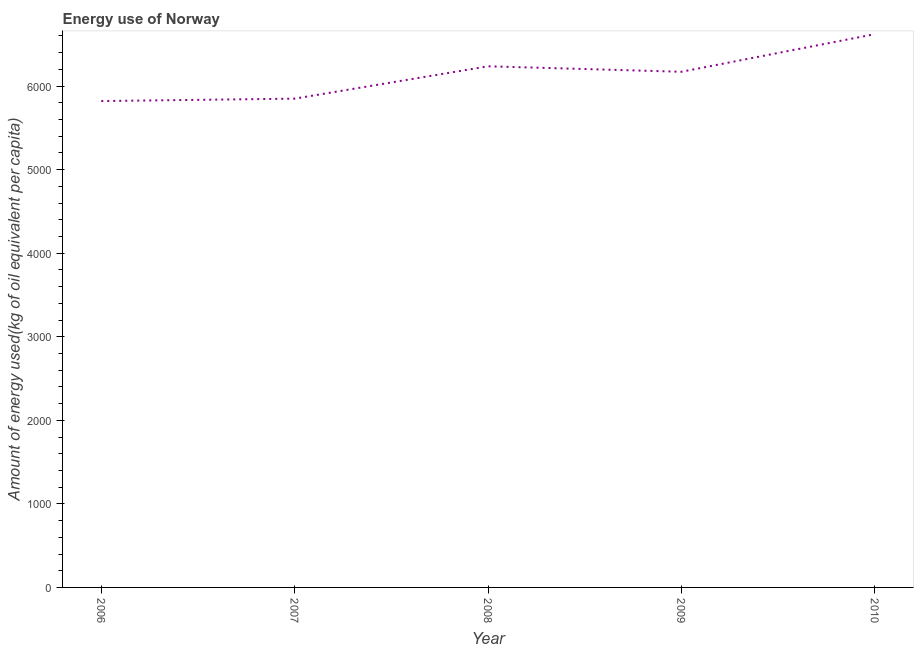What is the amount of energy used in 2006?
Your answer should be very brief. 5820.81. Across all years, what is the maximum amount of energy used?
Offer a very short reply. 6621.38. Across all years, what is the minimum amount of energy used?
Offer a terse response. 5820.81. In which year was the amount of energy used minimum?
Your answer should be compact. 2006. What is the sum of the amount of energy used?
Ensure brevity in your answer.  3.07e+04. What is the difference between the amount of energy used in 2006 and 2009?
Give a very brief answer. -350.56. What is the average amount of energy used per year?
Keep it short and to the point. 6140.03. What is the median amount of energy used?
Keep it short and to the point. 6171.37. In how many years, is the amount of energy used greater than 4800 kg?
Provide a short and direct response. 5. Do a majority of the years between 2010 and 2007 (inclusive) have amount of energy used greater than 4200 kg?
Provide a short and direct response. Yes. What is the ratio of the amount of energy used in 2007 to that in 2008?
Offer a terse response. 0.94. Is the amount of energy used in 2008 less than that in 2009?
Offer a terse response. No. What is the difference between the highest and the second highest amount of energy used?
Make the answer very short. 384.53. What is the difference between the highest and the lowest amount of energy used?
Offer a terse response. 800.57. In how many years, is the amount of energy used greater than the average amount of energy used taken over all years?
Your answer should be compact. 3. How many years are there in the graph?
Give a very brief answer. 5. What is the difference between two consecutive major ticks on the Y-axis?
Keep it short and to the point. 1000. Does the graph contain any zero values?
Ensure brevity in your answer.  No. Does the graph contain grids?
Your answer should be very brief. No. What is the title of the graph?
Keep it short and to the point. Energy use of Norway. What is the label or title of the Y-axis?
Your answer should be very brief. Amount of energy used(kg of oil equivalent per capita). What is the Amount of energy used(kg of oil equivalent per capita) in 2006?
Offer a very short reply. 5820.81. What is the Amount of energy used(kg of oil equivalent per capita) in 2007?
Provide a succinct answer. 5849.73. What is the Amount of energy used(kg of oil equivalent per capita) in 2008?
Give a very brief answer. 6236.85. What is the Amount of energy used(kg of oil equivalent per capita) of 2009?
Provide a short and direct response. 6171.37. What is the Amount of energy used(kg of oil equivalent per capita) of 2010?
Provide a short and direct response. 6621.38. What is the difference between the Amount of energy used(kg of oil equivalent per capita) in 2006 and 2007?
Make the answer very short. -28.93. What is the difference between the Amount of energy used(kg of oil equivalent per capita) in 2006 and 2008?
Your answer should be very brief. -416.04. What is the difference between the Amount of energy used(kg of oil equivalent per capita) in 2006 and 2009?
Your answer should be compact. -350.56. What is the difference between the Amount of energy used(kg of oil equivalent per capita) in 2006 and 2010?
Your answer should be compact. -800.57. What is the difference between the Amount of energy used(kg of oil equivalent per capita) in 2007 and 2008?
Your response must be concise. -387.12. What is the difference between the Amount of energy used(kg of oil equivalent per capita) in 2007 and 2009?
Your answer should be very brief. -321.64. What is the difference between the Amount of energy used(kg of oil equivalent per capita) in 2007 and 2010?
Keep it short and to the point. -771.64. What is the difference between the Amount of energy used(kg of oil equivalent per capita) in 2008 and 2009?
Your answer should be very brief. 65.48. What is the difference between the Amount of energy used(kg of oil equivalent per capita) in 2008 and 2010?
Keep it short and to the point. -384.53. What is the difference between the Amount of energy used(kg of oil equivalent per capita) in 2009 and 2010?
Provide a short and direct response. -450.01. What is the ratio of the Amount of energy used(kg of oil equivalent per capita) in 2006 to that in 2008?
Offer a terse response. 0.93. What is the ratio of the Amount of energy used(kg of oil equivalent per capita) in 2006 to that in 2009?
Your response must be concise. 0.94. What is the ratio of the Amount of energy used(kg of oil equivalent per capita) in 2006 to that in 2010?
Give a very brief answer. 0.88. What is the ratio of the Amount of energy used(kg of oil equivalent per capita) in 2007 to that in 2008?
Give a very brief answer. 0.94. What is the ratio of the Amount of energy used(kg of oil equivalent per capita) in 2007 to that in 2009?
Offer a terse response. 0.95. What is the ratio of the Amount of energy used(kg of oil equivalent per capita) in 2007 to that in 2010?
Ensure brevity in your answer.  0.88. What is the ratio of the Amount of energy used(kg of oil equivalent per capita) in 2008 to that in 2009?
Give a very brief answer. 1.01. What is the ratio of the Amount of energy used(kg of oil equivalent per capita) in 2008 to that in 2010?
Your answer should be very brief. 0.94. What is the ratio of the Amount of energy used(kg of oil equivalent per capita) in 2009 to that in 2010?
Offer a terse response. 0.93. 